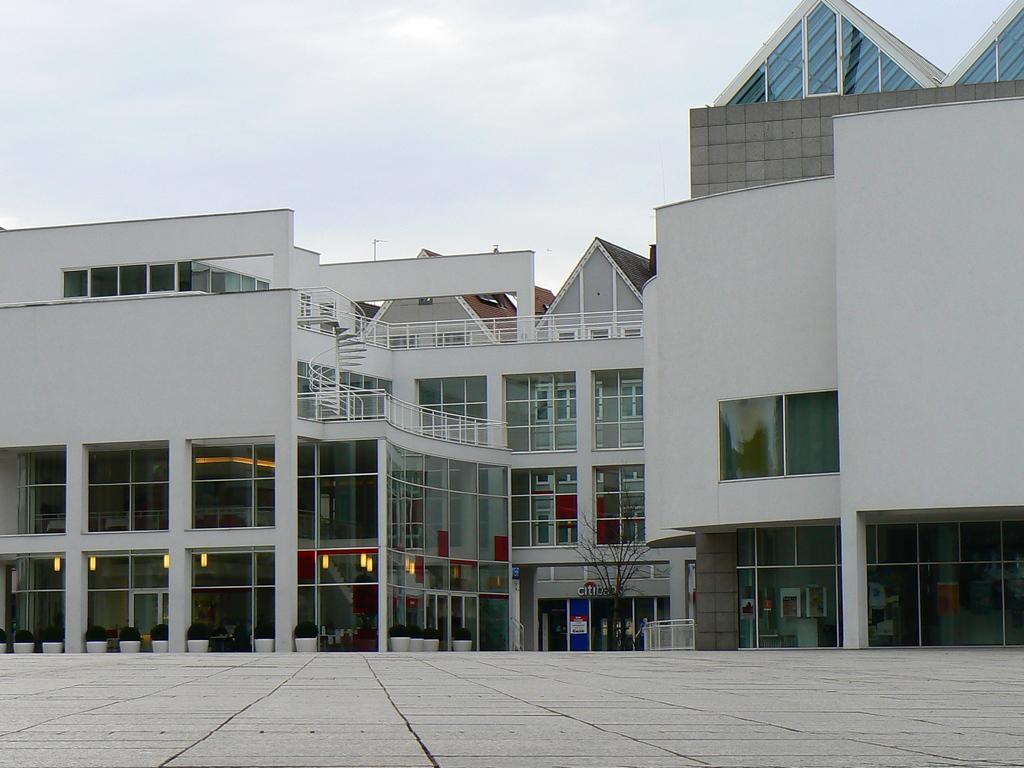Could you give a brief overview of what you see in this image? In this image we can see a building. On the building we can see the windows with glass. Inside the building we can see the lights. In front of the building we can see the plants and a tree. At the top we can see the sky. 